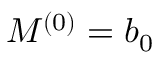<formula> <loc_0><loc_0><loc_500><loc_500>M ^ { ( 0 ) } = b _ { 0 }</formula> 